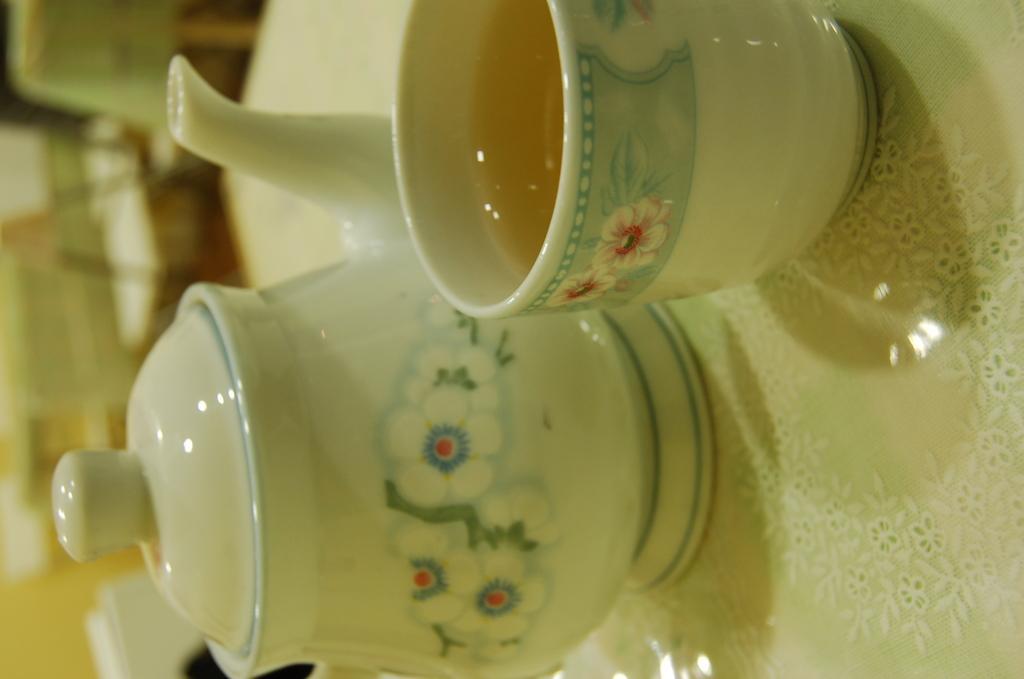Can you describe this image briefly? In this image, we can see a cup with liquid and kettle with a lid on the white surface. On the left side of the image, there is a blur view. 